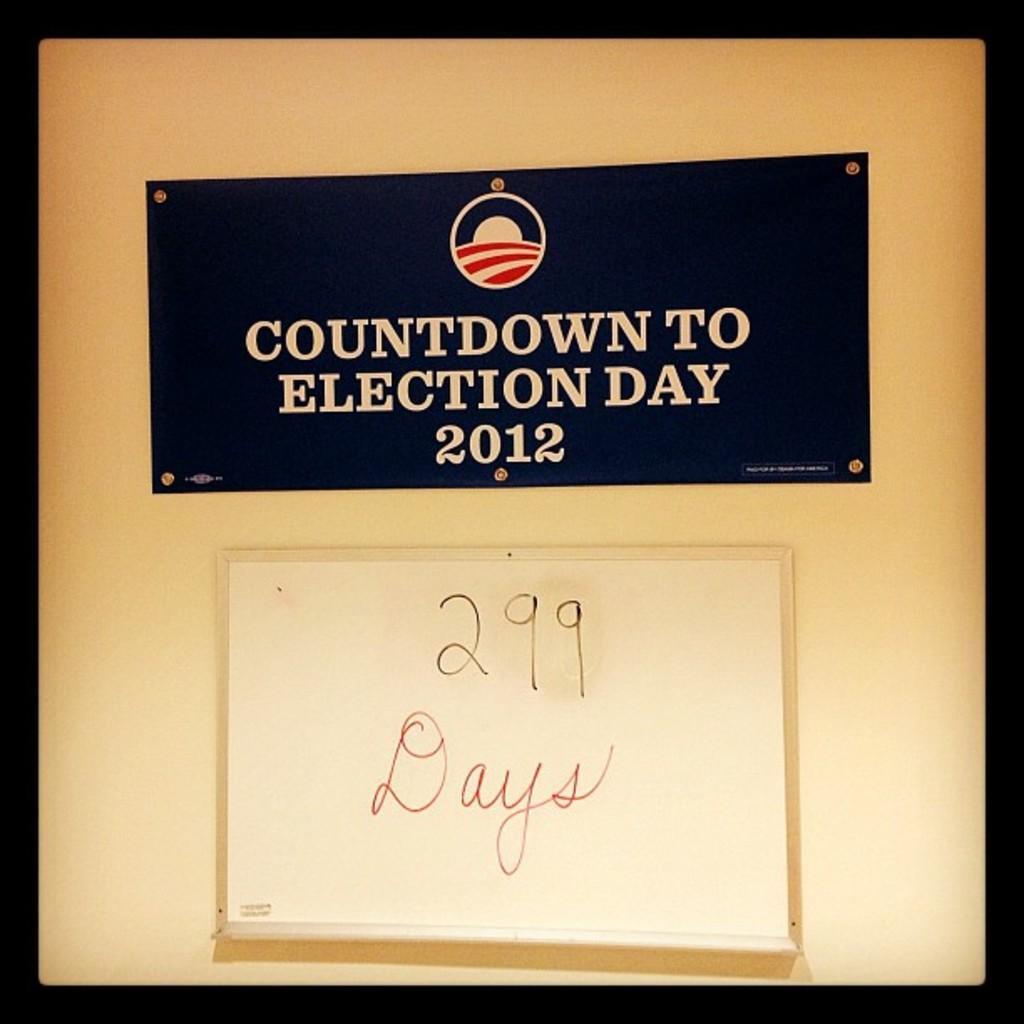Could you give a brief overview of what you see in this image? In the image in the center, we can see one banner. On the banner, it is written as "Countdown To Election Day 2012". And we can see the black color border around the image. 